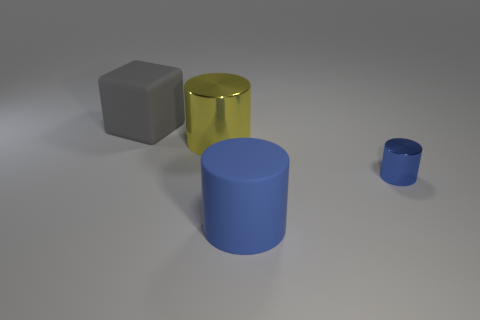Add 4 small brown cubes. How many objects exist? 8 Subtract all cylinders. How many objects are left? 1 Add 2 blue cylinders. How many blue cylinders exist? 4 Subtract 0 brown cylinders. How many objects are left? 4 Subtract all big blue matte things. Subtract all small cylinders. How many objects are left? 2 Add 2 blue metallic objects. How many blue metallic objects are left? 3 